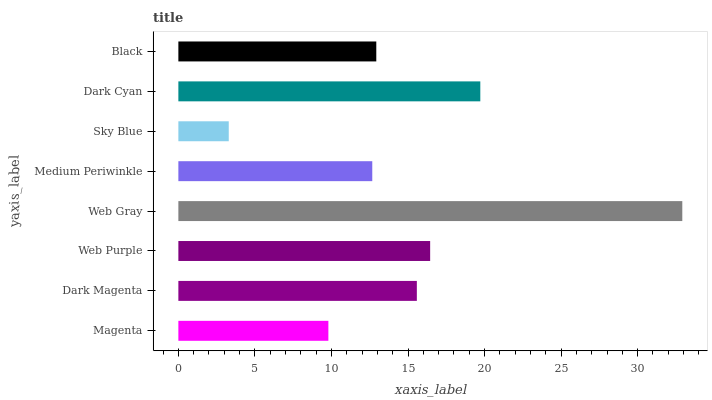Is Sky Blue the minimum?
Answer yes or no. Yes. Is Web Gray the maximum?
Answer yes or no. Yes. Is Dark Magenta the minimum?
Answer yes or no. No. Is Dark Magenta the maximum?
Answer yes or no. No. Is Dark Magenta greater than Magenta?
Answer yes or no. Yes. Is Magenta less than Dark Magenta?
Answer yes or no. Yes. Is Magenta greater than Dark Magenta?
Answer yes or no. No. Is Dark Magenta less than Magenta?
Answer yes or no. No. Is Dark Magenta the high median?
Answer yes or no. Yes. Is Black the low median?
Answer yes or no. Yes. Is Web Purple the high median?
Answer yes or no. No. Is Dark Cyan the low median?
Answer yes or no. No. 